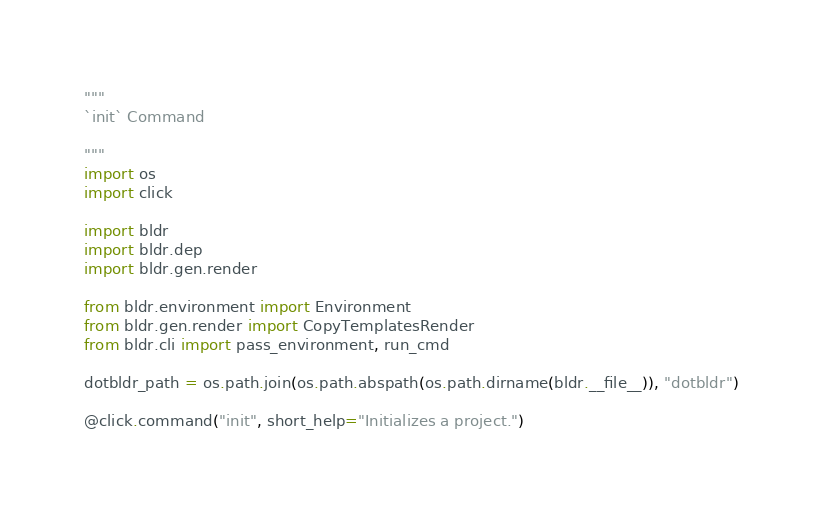Convert code to text. <code><loc_0><loc_0><loc_500><loc_500><_Python_>"""
`init` Command

"""
import os
import click

import bldr
import bldr.dep
import bldr.gen.render

from bldr.environment import Environment
from bldr.gen.render import CopyTemplatesRender
from bldr.cli import pass_environment, run_cmd

dotbldr_path = os.path.join(os.path.abspath(os.path.dirname(bldr.__file__)), "dotbldr")

@click.command("init", short_help="Initializes a project.")</code> 